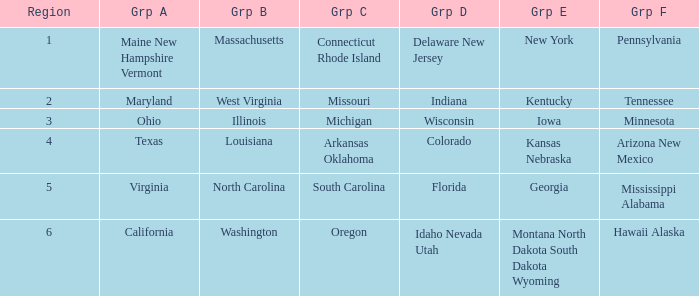What is the group C region with Illinois as group B? Michigan. 